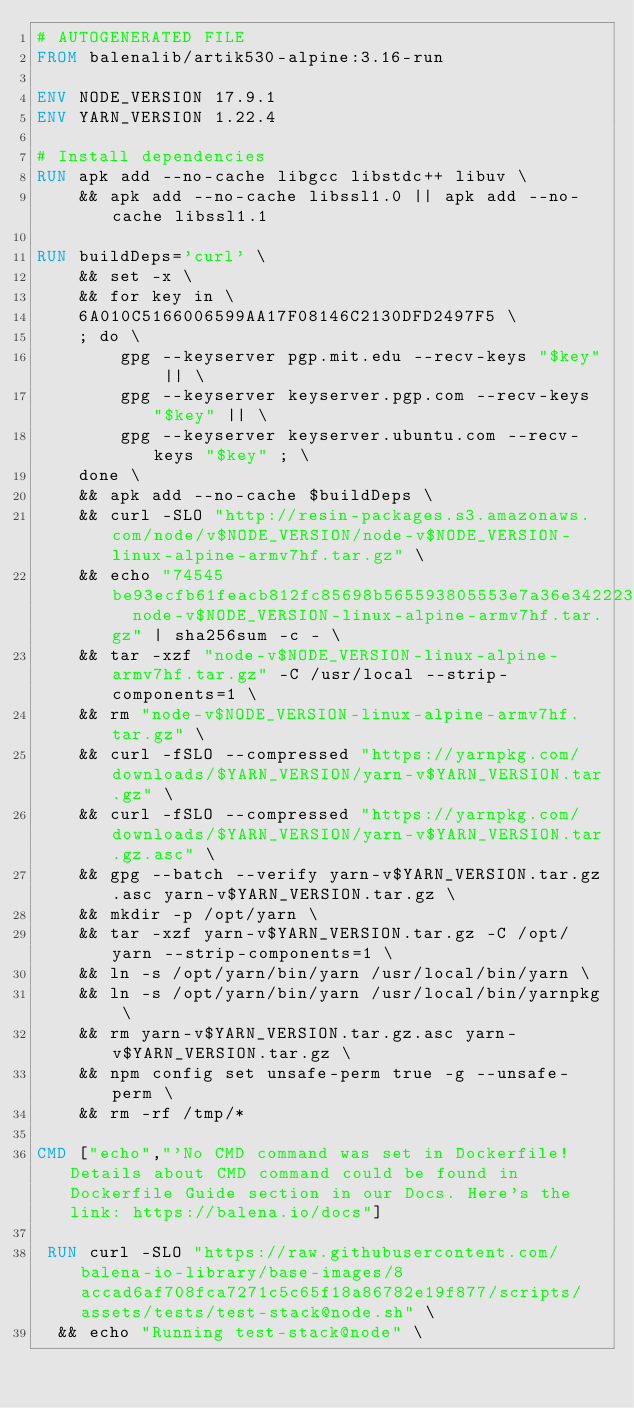<code> <loc_0><loc_0><loc_500><loc_500><_Dockerfile_># AUTOGENERATED FILE
FROM balenalib/artik530-alpine:3.16-run

ENV NODE_VERSION 17.9.1
ENV YARN_VERSION 1.22.4

# Install dependencies
RUN apk add --no-cache libgcc libstdc++ libuv \
	&& apk add --no-cache libssl1.0 || apk add --no-cache libssl1.1

RUN buildDeps='curl' \
	&& set -x \
	&& for key in \
	6A010C5166006599AA17F08146C2130DFD2497F5 \
	; do \
		gpg --keyserver pgp.mit.edu --recv-keys "$key" || \
		gpg --keyserver keyserver.pgp.com --recv-keys "$key" || \
		gpg --keyserver keyserver.ubuntu.com --recv-keys "$key" ; \
	done \
	&& apk add --no-cache $buildDeps \
	&& curl -SLO "http://resin-packages.s3.amazonaws.com/node/v$NODE_VERSION/node-v$NODE_VERSION-linux-alpine-armv7hf.tar.gz" \
	&& echo "74545be93ecfb61feacb812fc85698b565593805553e7a36e3422232724a7746  node-v$NODE_VERSION-linux-alpine-armv7hf.tar.gz" | sha256sum -c - \
	&& tar -xzf "node-v$NODE_VERSION-linux-alpine-armv7hf.tar.gz" -C /usr/local --strip-components=1 \
	&& rm "node-v$NODE_VERSION-linux-alpine-armv7hf.tar.gz" \
	&& curl -fSLO --compressed "https://yarnpkg.com/downloads/$YARN_VERSION/yarn-v$YARN_VERSION.tar.gz" \
	&& curl -fSLO --compressed "https://yarnpkg.com/downloads/$YARN_VERSION/yarn-v$YARN_VERSION.tar.gz.asc" \
	&& gpg --batch --verify yarn-v$YARN_VERSION.tar.gz.asc yarn-v$YARN_VERSION.tar.gz \
	&& mkdir -p /opt/yarn \
	&& tar -xzf yarn-v$YARN_VERSION.tar.gz -C /opt/yarn --strip-components=1 \
	&& ln -s /opt/yarn/bin/yarn /usr/local/bin/yarn \
	&& ln -s /opt/yarn/bin/yarn /usr/local/bin/yarnpkg \
	&& rm yarn-v$YARN_VERSION.tar.gz.asc yarn-v$YARN_VERSION.tar.gz \
	&& npm config set unsafe-perm true -g --unsafe-perm \
	&& rm -rf /tmp/*

CMD ["echo","'No CMD command was set in Dockerfile! Details about CMD command could be found in Dockerfile Guide section in our Docs. Here's the link: https://balena.io/docs"]

 RUN curl -SLO "https://raw.githubusercontent.com/balena-io-library/base-images/8accad6af708fca7271c5c65f18a86782e19f877/scripts/assets/tests/test-stack@node.sh" \
  && echo "Running test-stack@node" \</code> 